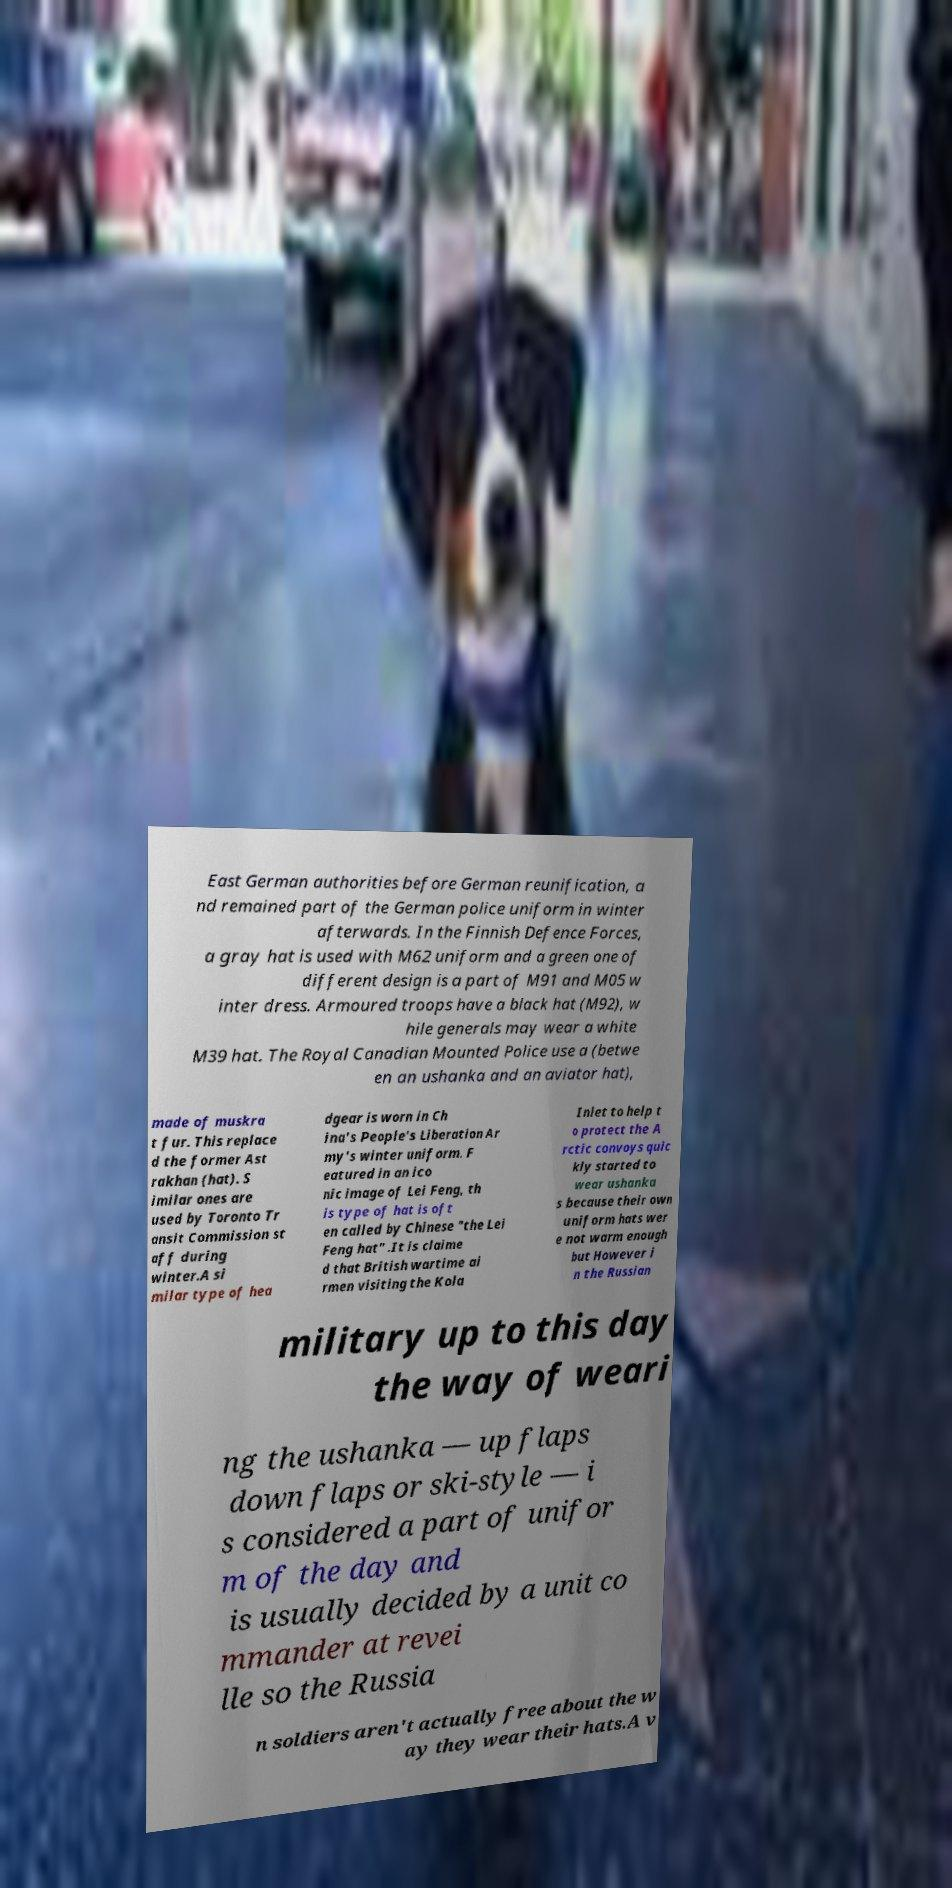Please read and relay the text visible in this image. What does it say? East German authorities before German reunification, a nd remained part of the German police uniform in winter afterwards. In the Finnish Defence Forces, a gray hat is used with M62 uniform and a green one of different design is a part of M91 and M05 w inter dress. Armoured troops have a black hat (M92), w hile generals may wear a white M39 hat. The Royal Canadian Mounted Police use a (betwe en an ushanka and an aviator hat), made of muskra t fur. This replace d the former Ast rakhan (hat). S imilar ones are used by Toronto Tr ansit Commission st aff during winter.A si milar type of hea dgear is worn in Ch ina's People's Liberation Ar my's winter uniform. F eatured in an ico nic image of Lei Feng, th is type of hat is oft en called by Chinese "the Lei Feng hat" .It is claime d that British wartime ai rmen visiting the Kola Inlet to help t o protect the A rctic convoys quic kly started to wear ushanka s because their own uniform hats wer e not warm enough but However i n the Russian military up to this day the way of weari ng the ushanka — up flaps down flaps or ski-style — i s considered a part of unifor m of the day and is usually decided by a unit co mmander at revei lle so the Russia n soldiers aren't actually free about the w ay they wear their hats.A v 